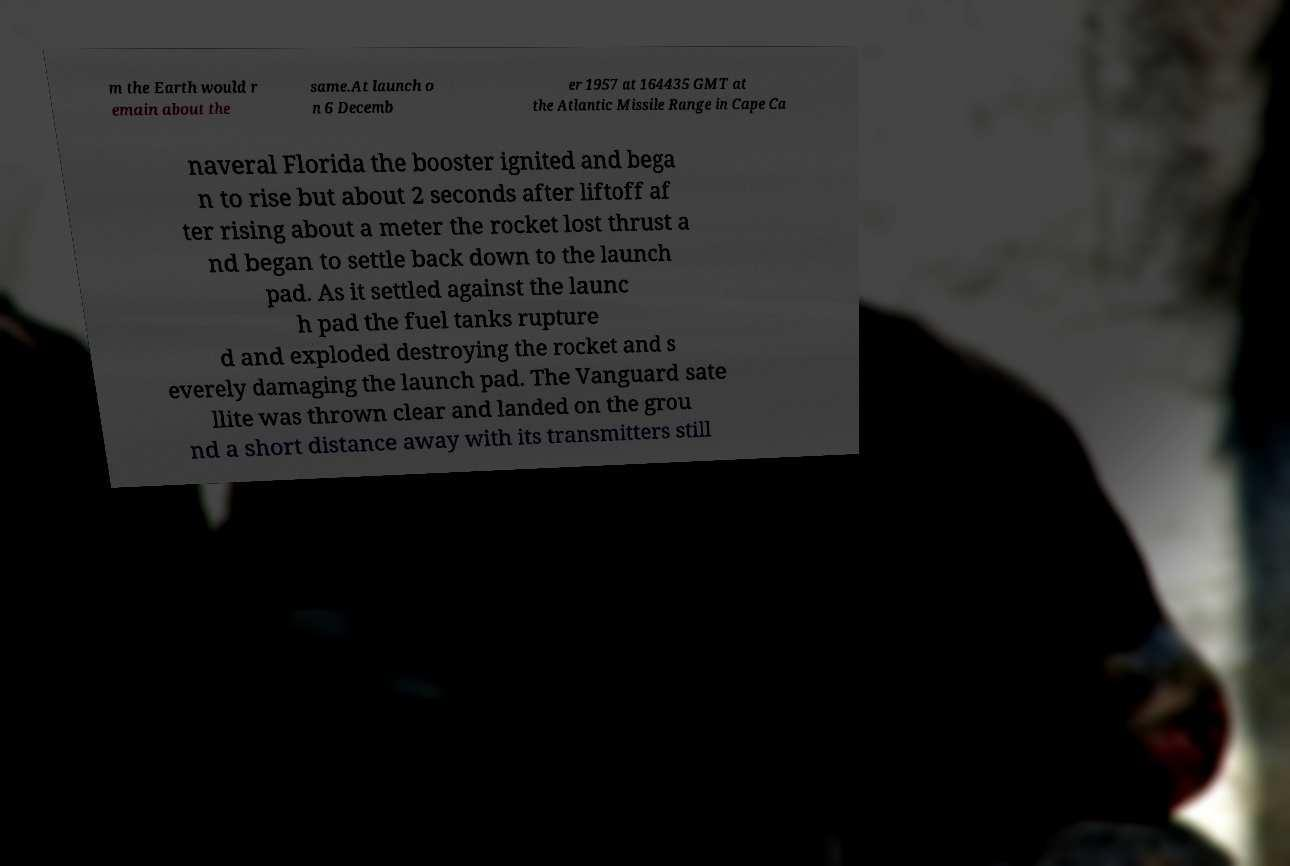Can you read and provide the text displayed in the image?This photo seems to have some interesting text. Can you extract and type it out for me? m the Earth would r emain about the same.At launch o n 6 Decemb er 1957 at 164435 GMT at the Atlantic Missile Range in Cape Ca naveral Florida the booster ignited and bega n to rise but about 2 seconds after liftoff af ter rising about a meter the rocket lost thrust a nd began to settle back down to the launch pad. As it settled against the launc h pad the fuel tanks rupture d and exploded destroying the rocket and s everely damaging the launch pad. The Vanguard sate llite was thrown clear and landed on the grou nd a short distance away with its transmitters still 